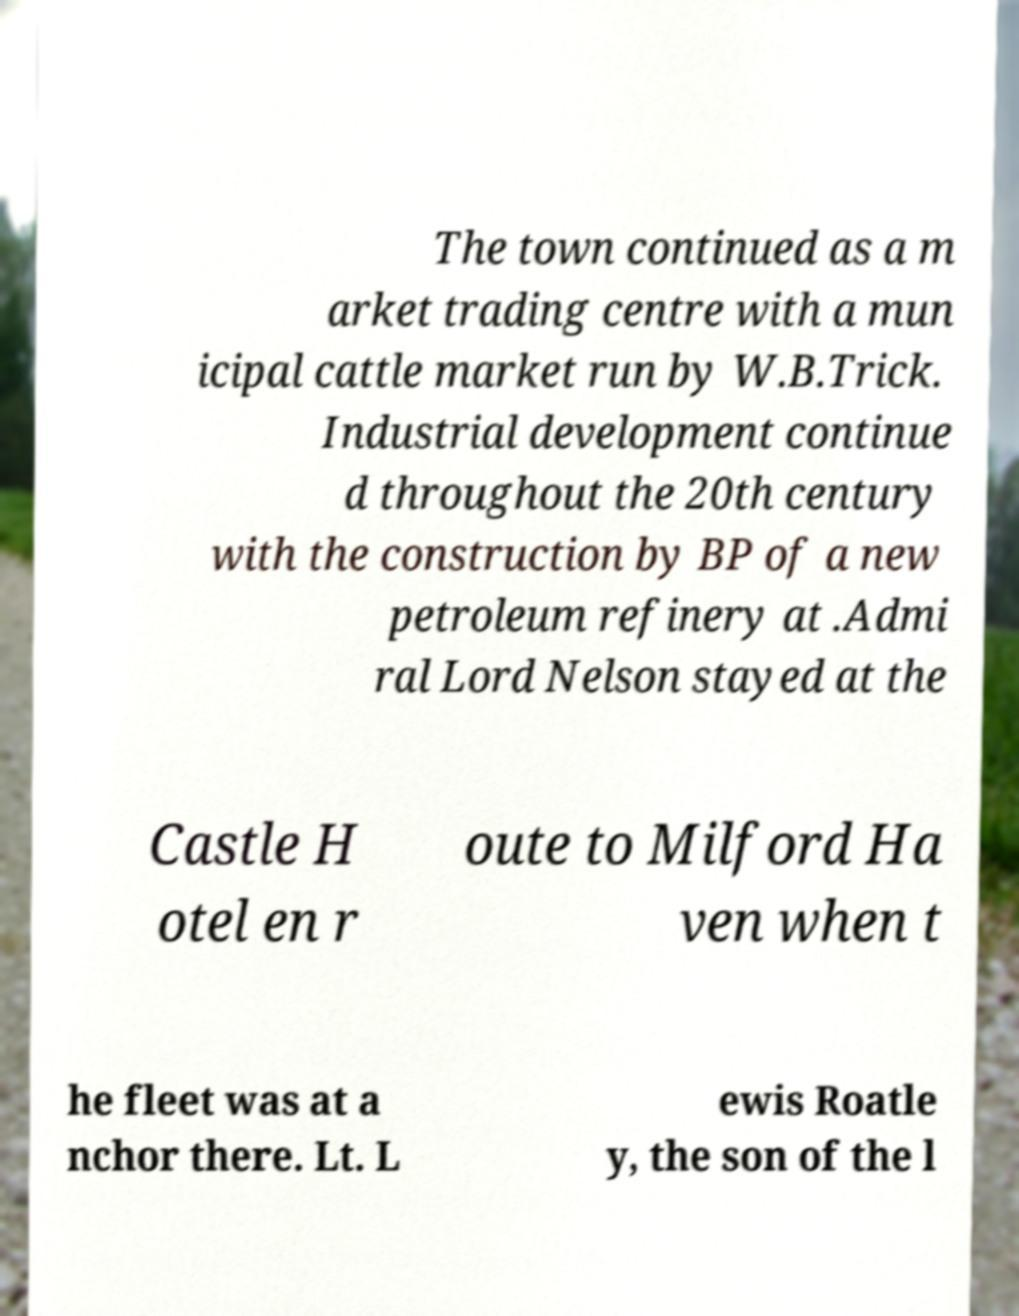There's text embedded in this image that I need extracted. Can you transcribe it verbatim? The town continued as a m arket trading centre with a mun icipal cattle market run by W.B.Trick. Industrial development continue d throughout the 20th century with the construction by BP of a new petroleum refinery at .Admi ral Lord Nelson stayed at the Castle H otel en r oute to Milford Ha ven when t he fleet was at a nchor there. Lt. L ewis Roatle y, the son of the l 